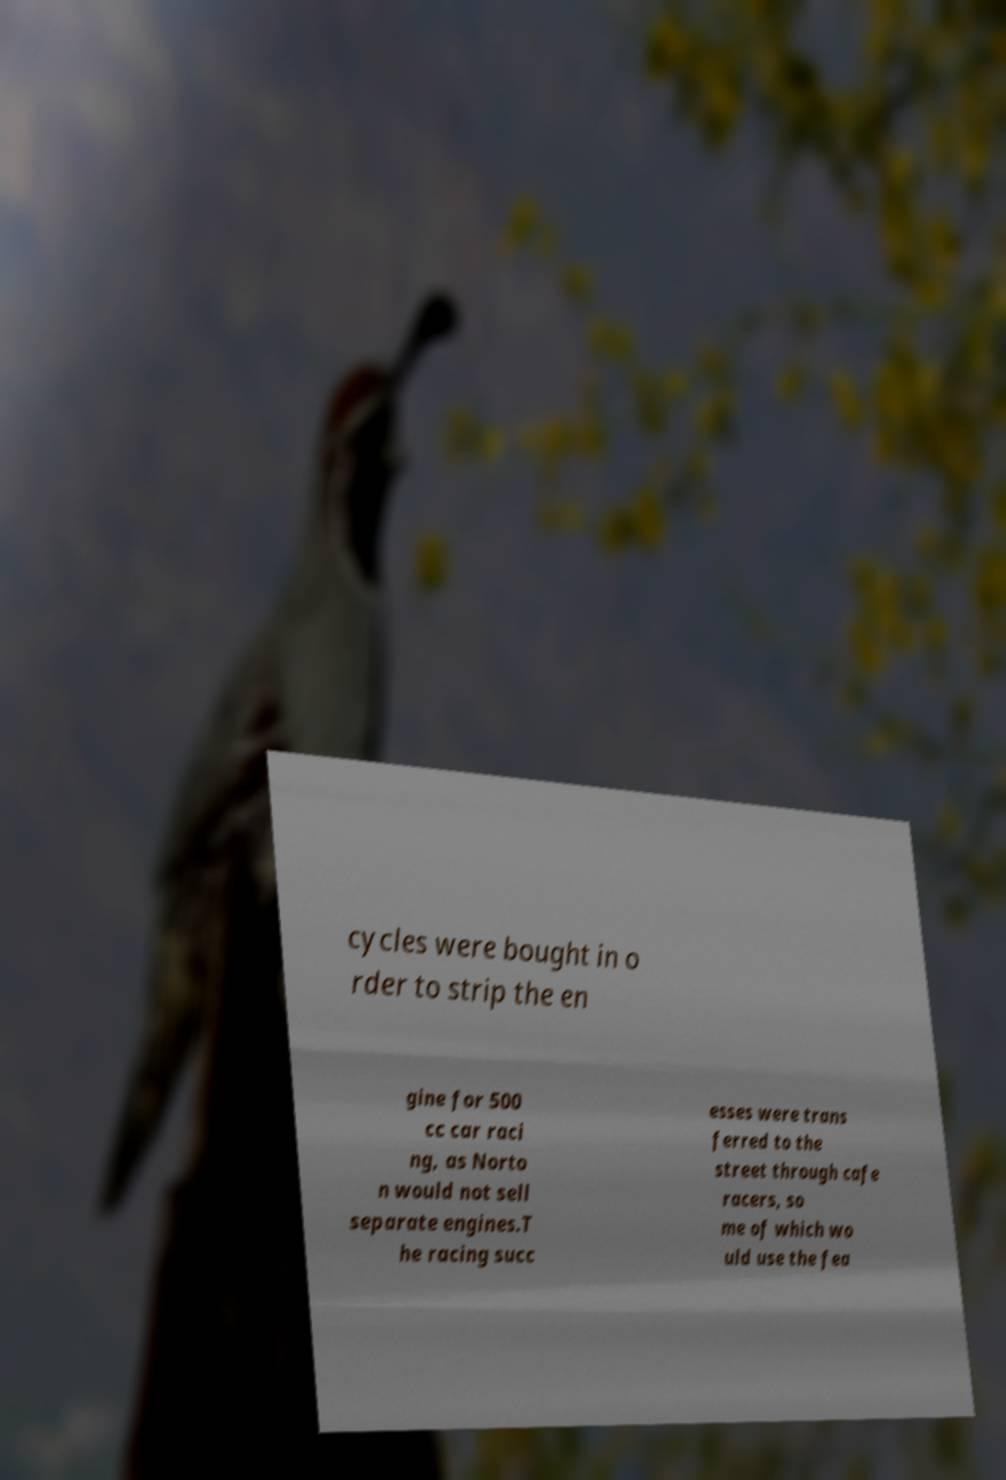Can you accurately transcribe the text from the provided image for me? cycles were bought in o rder to strip the en gine for 500 cc car raci ng, as Norto n would not sell separate engines.T he racing succ esses were trans ferred to the street through cafe racers, so me of which wo uld use the fea 